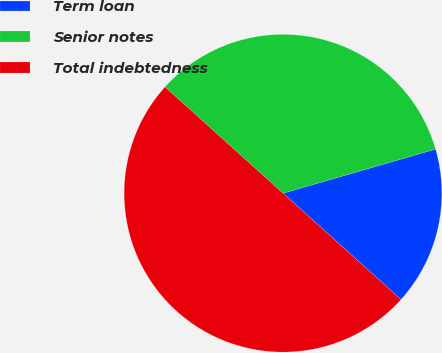Convert chart to OTSL. <chart><loc_0><loc_0><loc_500><loc_500><pie_chart><fcel>Term loan<fcel>Senior notes<fcel>Total indebtedness<nl><fcel>16.15%<fcel>33.85%<fcel>50.0%<nl></chart> 